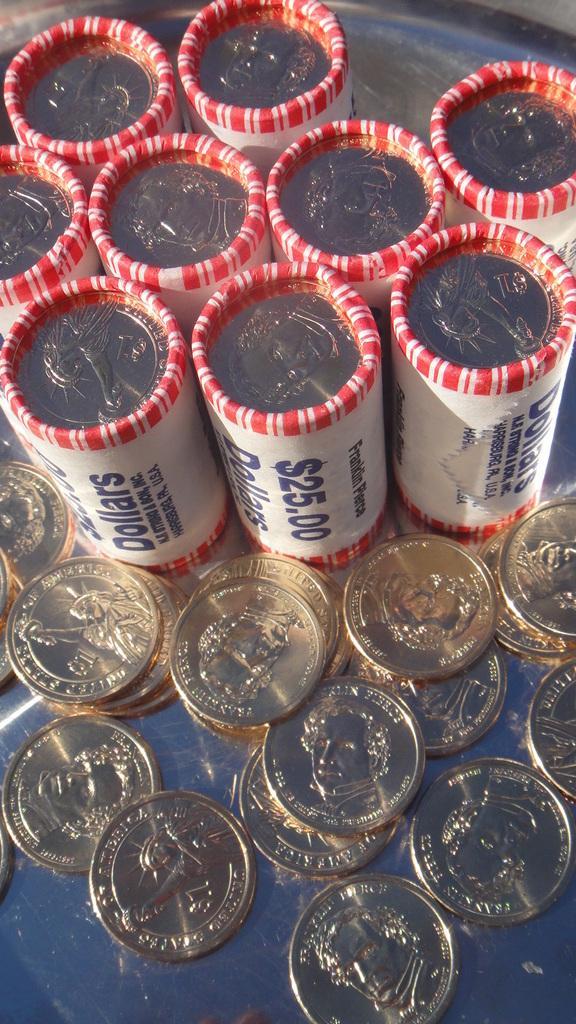Describe this image in one or two sentences. In this image at the bottom there are some coins and in the center there are some packets, and in that packets there are a group of coins. 